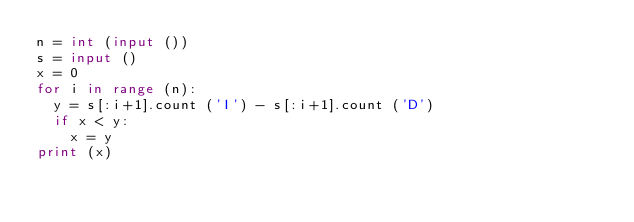<code> <loc_0><loc_0><loc_500><loc_500><_Python_>n = int (input ())
s = input ()
x = 0
for i in range (n):
  y = s[:i+1].count ('I') - s[:i+1].count ('D')
  if x < y:
    x = y
print (x)</code> 